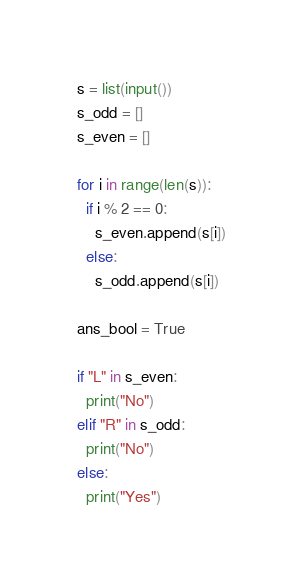<code> <loc_0><loc_0><loc_500><loc_500><_Python_>s = list(input())
s_odd = []
s_even = []

for i in range(len(s)):
  if i % 2 == 0:
    s_even.append(s[i])
  else:
    s_odd.append(s[i])

ans_bool = True

if "L" in s_even:
  print("No")
elif "R" in s_odd:
  print("No")
else:
  print("Yes")</code> 